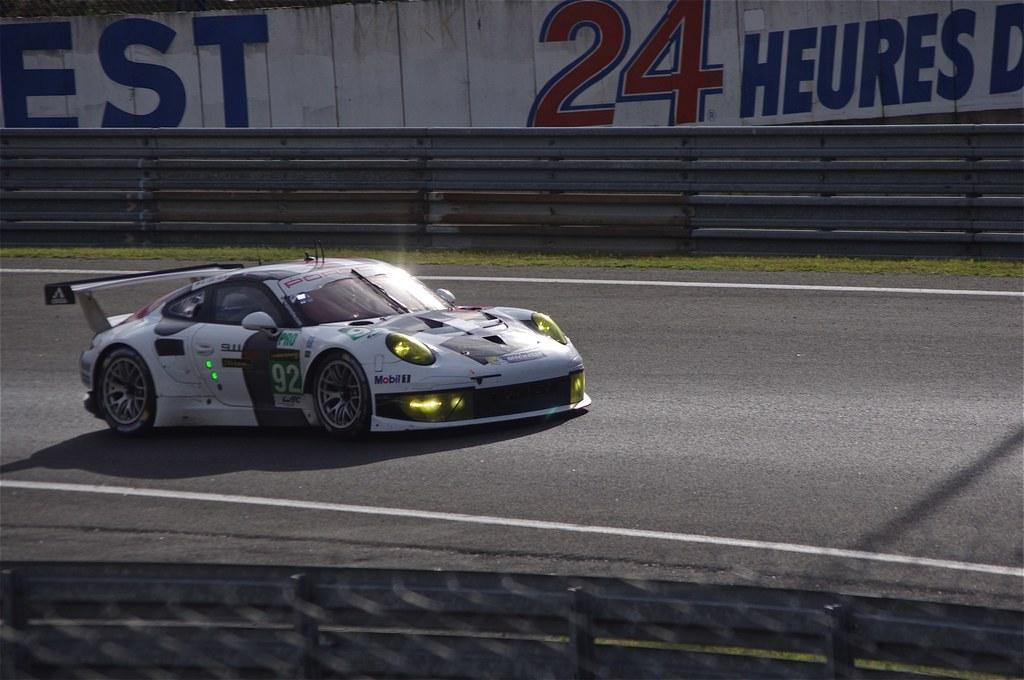What is the main subject of the image? There is a car in the image. What is the car doing in the image? The car is moving on the road. What color is the car? The car is white in color. What can be seen in the background of the image? There is a wall visible in the background of the image. Can you tell me how many zebras are standing next to the car in the image? There are no zebras present in the image; it features a car moving on the road with a wall visible in the background. 